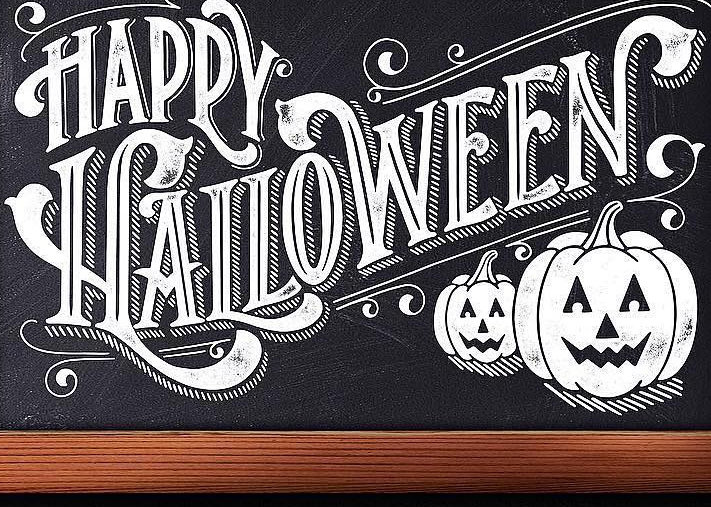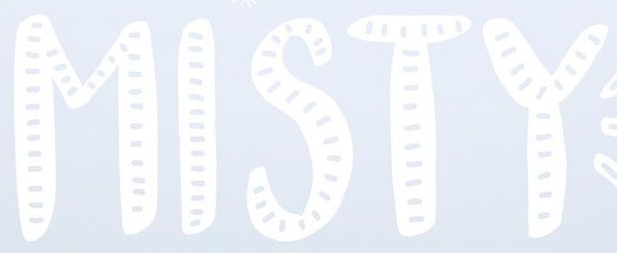Identify the words shown in these images in order, separated by a semicolon. HALLOWEEN; MISTY 